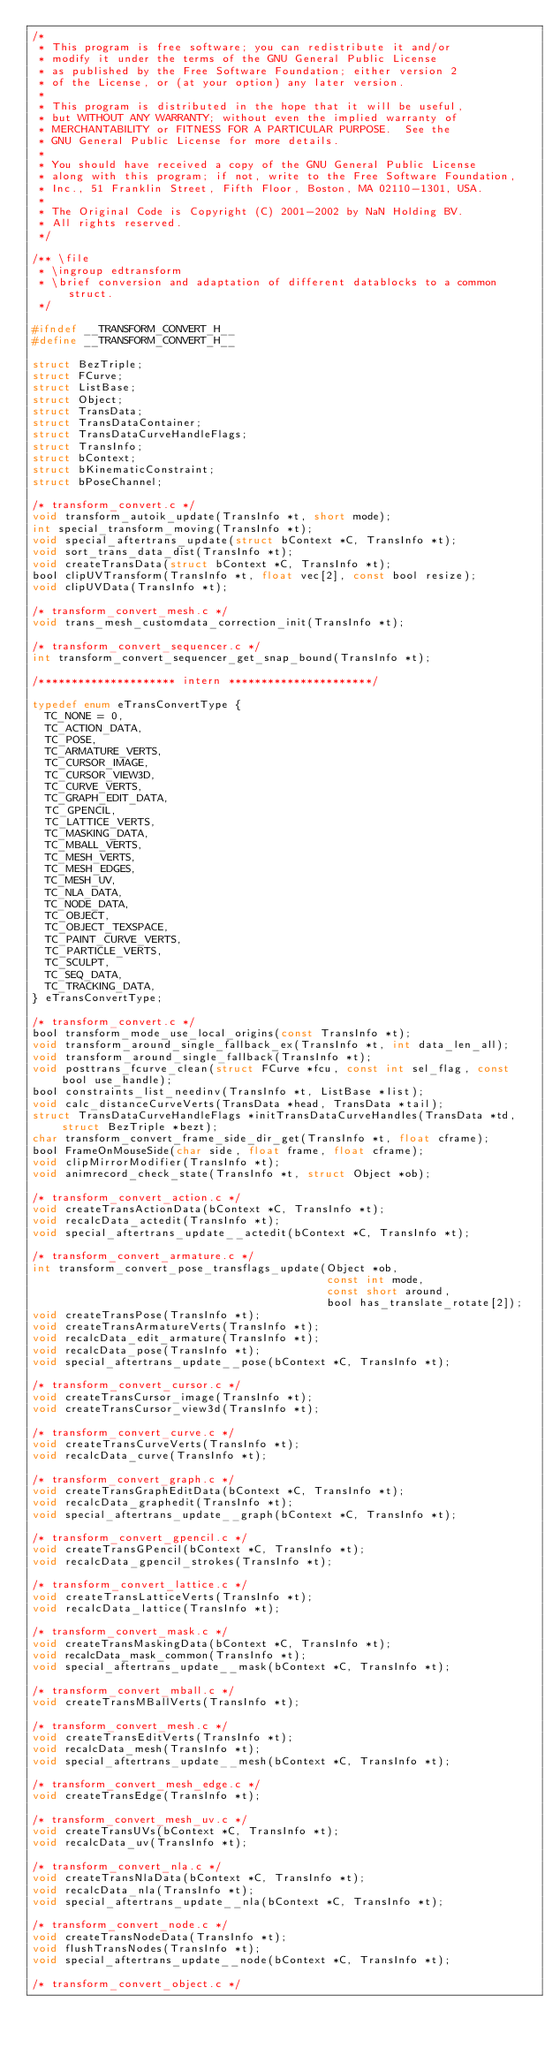<code> <loc_0><loc_0><loc_500><loc_500><_C_>/*
 * This program is free software; you can redistribute it and/or
 * modify it under the terms of the GNU General Public License
 * as published by the Free Software Foundation; either version 2
 * of the License, or (at your option) any later version.
 *
 * This program is distributed in the hope that it will be useful,
 * but WITHOUT ANY WARRANTY; without even the implied warranty of
 * MERCHANTABILITY or FITNESS FOR A PARTICULAR PURPOSE.  See the
 * GNU General Public License for more details.
 *
 * You should have received a copy of the GNU General Public License
 * along with this program; if not, write to the Free Software Foundation,
 * Inc., 51 Franklin Street, Fifth Floor, Boston, MA 02110-1301, USA.
 *
 * The Original Code is Copyright (C) 2001-2002 by NaN Holding BV.
 * All rights reserved.
 */

/** \file
 * \ingroup edtransform
 * \brief conversion and adaptation of different datablocks to a common struct.
 */

#ifndef __TRANSFORM_CONVERT_H__
#define __TRANSFORM_CONVERT_H__

struct BezTriple;
struct FCurve;
struct ListBase;
struct Object;
struct TransData;
struct TransDataContainer;
struct TransDataCurveHandleFlags;
struct TransInfo;
struct bContext;
struct bKinematicConstraint;
struct bPoseChannel;

/* transform_convert.c */
void transform_autoik_update(TransInfo *t, short mode);
int special_transform_moving(TransInfo *t);
void special_aftertrans_update(struct bContext *C, TransInfo *t);
void sort_trans_data_dist(TransInfo *t);
void createTransData(struct bContext *C, TransInfo *t);
bool clipUVTransform(TransInfo *t, float vec[2], const bool resize);
void clipUVData(TransInfo *t);

/* transform_convert_mesh.c */
void trans_mesh_customdata_correction_init(TransInfo *t);

/* transform_convert_sequencer.c */
int transform_convert_sequencer_get_snap_bound(TransInfo *t);

/********************* intern **********************/

typedef enum eTransConvertType {
  TC_NONE = 0,
  TC_ACTION_DATA,
  TC_POSE,
  TC_ARMATURE_VERTS,
  TC_CURSOR_IMAGE,
  TC_CURSOR_VIEW3D,
  TC_CURVE_VERTS,
  TC_GRAPH_EDIT_DATA,
  TC_GPENCIL,
  TC_LATTICE_VERTS,
  TC_MASKING_DATA,
  TC_MBALL_VERTS,
  TC_MESH_VERTS,
  TC_MESH_EDGES,
  TC_MESH_UV,
  TC_NLA_DATA,
  TC_NODE_DATA,
  TC_OBJECT,
  TC_OBJECT_TEXSPACE,
  TC_PAINT_CURVE_VERTS,
  TC_PARTICLE_VERTS,
  TC_SCULPT,
  TC_SEQ_DATA,
  TC_TRACKING_DATA,
} eTransConvertType;

/* transform_convert.c */
bool transform_mode_use_local_origins(const TransInfo *t);
void transform_around_single_fallback_ex(TransInfo *t, int data_len_all);
void transform_around_single_fallback(TransInfo *t);
void posttrans_fcurve_clean(struct FCurve *fcu, const int sel_flag, const bool use_handle);
bool constraints_list_needinv(TransInfo *t, ListBase *list);
void calc_distanceCurveVerts(TransData *head, TransData *tail);
struct TransDataCurveHandleFlags *initTransDataCurveHandles(TransData *td, struct BezTriple *bezt);
char transform_convert_frame_side_dir_get(TransInfo *t, float cframe);
bool FrameOnMouseSide(char side, float frame, float cframe);
void clipMirrorModifier(TransInfo *t);
void animrecord_check_state(TransInfo *t, struct Object *ob);

/* transform_convert_action.c */
void createTransActionData(bContext *C, TransInfo *t);
void recalcData_actedit(TransInfo *t);
void special_aftertrans_update__actedit(bContext *C, TransInfo *t);

/* transform_convert_armature.c */
int transform_convert_pose_transflags_update(Object *ob,
                                             const int mode,
                                             const short around,
                                             bool has_translate_rotate[2]);
void createTransPose(TransInfo *t);
void createTransArmatureVerts(TransInfo *t);
void recalcData_edit_armature(TransInfo *t);
void recalcData_pose(TransInfo *t);
void special_aftertrans_update__pose(bContext *C, TransInfo *t);

/* transform_convert_cursor.c */
void createTransCursor_image(TransInfo *t);
void createTransCursor_view3d(TransInfo *t);

/* transform_convert_curve.c */
void createTransCurveVerts(TransInfo *t);
void recalcData_curve(TransInfo *t);

/* transform_convert_graph.c */
void createTransGraphEditData(bContext *C, TransInfo *t);
void recalcData_graphedit(TransInfo *t);
void special_aftertrans_update__graph(bContext *C, TransInfo *t);

/* transform_convert_gpencil.c */
void createTransGPencil(bContext *C, TransInfo *t);
void recalcData_gpencil_strokes(TransInfo *t);

/* transform_convert_lattice.c */
void createTransLatticeVerts(TransInfo *t);
void recalcData_lattice(TransInfo *t);

/* transform_convert_mask.c */
void createTransMaskingData(bContext *C, TransInfo *t);
void recalcData_mask_common(TransInfo *t);
void special_aftertrans_update__mask(bContext *C, TransInfo *t);

/* transform_convert_mball.c */
void createTransMBallVerts(TransInfo *t);

/* transform_convert_mesh.c */
void createTransEditVerts(TransInfo *t);
void recalcData_mesh(TransInfo *t);
void special_aftertrans_update__mesh(bContext *C, TransInfo *t);

/* transform_convert_mesh_edge.c */
void createTransEdge(TransInfo *t);

/* transform_convert_mesh_uv.c */
void createTransUVs(bContext *C, TransInfo *t);
void recalcData_uv(TransInfo *t);

/* transform_convert_nla.c */
void createTransNlaData(bContext *C, TransInfo *t);
void recalcData_nla(TransInfo *t);
void special_aftertrans_update__nla(bContext *C, TransInfo *t);

/* transform_convert_node.c */
void createTransNodeData(TransInfo *t);
void flushTransNodes(TransInfo *t);
void special_aftertrans_update__node(bContext *C, TransInfo *t);

/* transform_convert_object.c */</code> 